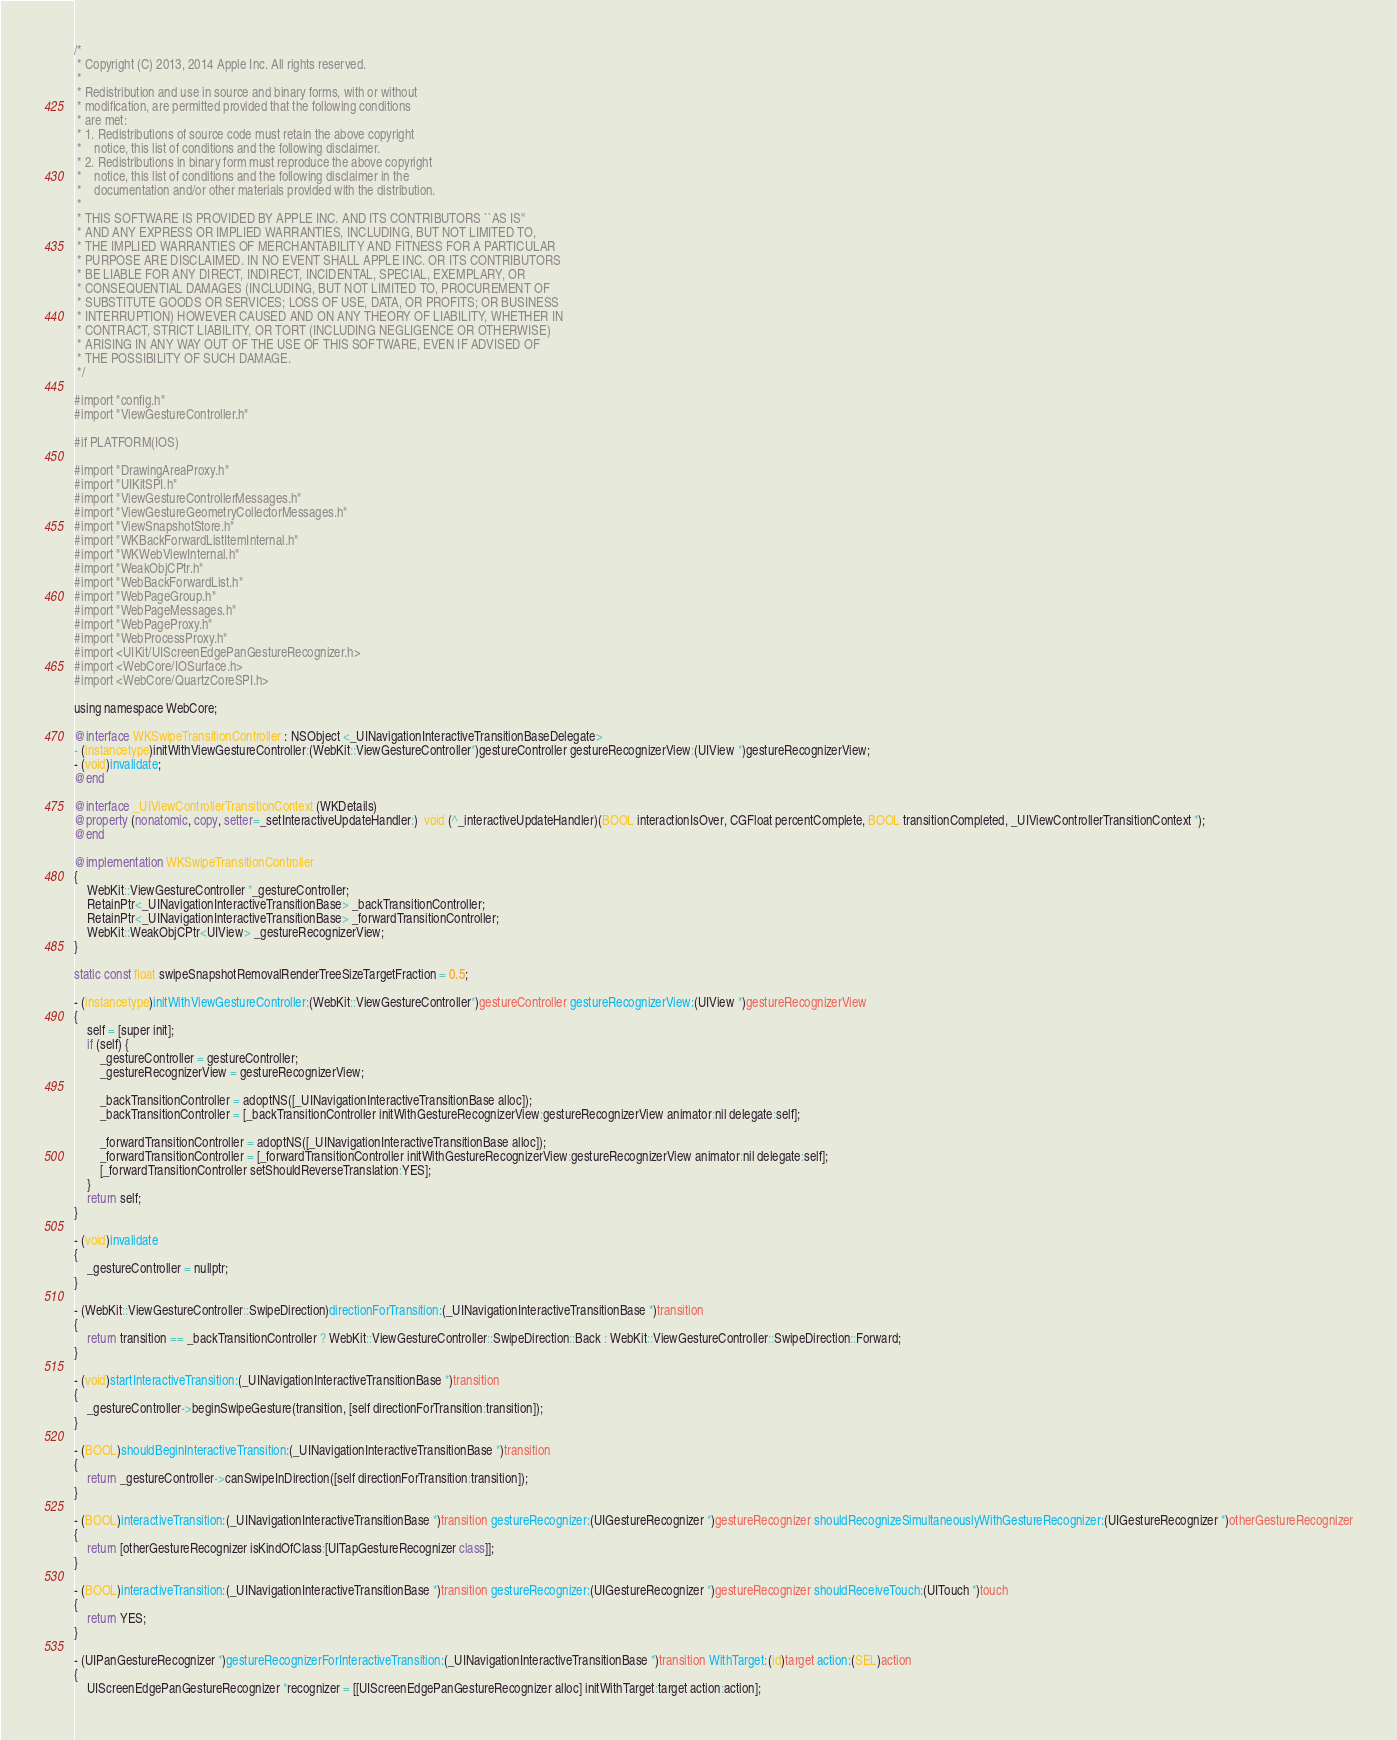<code> <loc_0><loc_0><loc_500><loc_500><_ObjectiveC_>/*
 * Copyright (C) 2013, 2014 Apple Inc. All rights reserved.
 *
 * Redistribution and use in source and binary forms, with or without
 * modification, are permitted provided that the following conditions
 * are met:
 * 1. Redistributions of source code must retain the above copyright
 *    notice, this list of conditions and the following disclaimer.
 * 2. Redistributions in binary form must reproduce the above copyright
 *    notice, this list of conditions and the following disclaimer in the
 *    documentation and/or other materials provided with the distribution.
 *
 * THIS SOFTWARE IS PROVIDED BY APPLE INC. AND ITS CONTRIBUTORS ``AS IS''
 * AND ANY EXPRESS OR IMPLIED WARRANTIES, INCLUDING, BUT NOT LIMITED TO,
 * THE IMPLIED WARRANTIES OF MERCHANTABILITY AND FITNESS FOR A PARTICULAR
 * PURPOSE ARE DISCLAIMED. IN NO EVENT SHALL APPLE INC. OR ITS CONTRIBUTORS
 * BE LIABLE FOR ANY DIRECT, INDIRECT, INCIDENTAL, SPECIAL, EXEMPLARY, OR
 * CONSEQUENTIAL DAMAGES (INCLUDING, BUT NOT LIMITED TO, PROCUREMENT OF
 * SUBSTITUTE GOODS OR SERVICES; LOSS OF USE, DATA, OR PROFITS; OR BUSINESS
 * INTERRUPTION) HOWEVER CAUSED AND ON ANY THEORY OF LIABILITY, WHETHER IN
 * CONTRACT, STRICT LIABILITY, OR TORT (INCLUDING NEGLIGENCE OR OTHERWISE)
 * ARISING IN ANY WAY OUT OF THE USE OF THIS SOFTWARE, EVEN IF ADVISED OF
 * THE POSSIBILITY OF SUCH DAMAGE.
 */

#import "config.h"
#import "ViewGestureController.h"

#if PLATFORM(IOS)

#import "DrawingAreaProxy.h"
#import "UIKitSPI.h"
#import "ViewGestureControllerMessages.h"
#import "ViewGestureGeometryCollectorMessages.h"
#import "ViewSnapshotStore.h"
#import "WKBackForwardListItemInternal.h"
#import "WKWebViewInternal.h"
#import "WeakObjCPtr.h"
#import "WebBackForwardList.h"
#import "WebPageGroup.h"
#import "WebPageMessages.h"
#import "WebPageProxy.h"
#import "WebProcessProxy.h"
#import <UIKit/UIScreenEdgePanGestureRecognizer.h>
#import <WebCore/IOSurface.h>
#import <WebCore/QuartzCoreSPI.h>

using namespace WebCore;

@interface WKSwipeTransitionController : NSObject <_UINavigationInteractiveTransitionBaseDelegate>
- (instancetype)initWithViewGestureController:(WebKit::ViewGestureController*)gestureController gestureRecognizerView:(UIView *)gestureRecognizerView;
- (void)invalidate;
@end

@interface _UIViewControllerTransitionContext (WKDetails)
@property (nonatomic, copy, setter=_setInteractiveUpdateHandler:)  void (^_interactiveUpdateHandler)(BOOL interactionIsOver, CGFloat percentComplete, BOOL transitionCompleted, _UIViewControllerTransitionContext *);
@end

@implementation WKSwipeTransitionController
{
    WebKit::ViewGestureController *_gestureController;
    RetainPtr<_UINavigationInteractiveTransitionBase> _backTransitionController;
    RetainPtr<_UINavigationInteractiveTransitionBase> _forwardTransitionController;
    WebKit::WeakObjCPtr<UIView> _gestureRecognizerView;
}

static const float swipeSnapshotRemovalRenderTreeSizeTargetFraction = 0.5;

- (instancetype)initWithViewGestureController:(WebKit::ViewGestureController*)gestureController gestureRecognizerView:(UIView *)gestureRecognizerView
{
    self = [super init];
    if (self) {
        _gestureController = gestureController;
        _gestureRecognizerView = gestureRecognizerView;

        _backTransitionController = adoptNS([_UINavigationInteractiveTransitionBase alloc]);
        _backTransitionController = [_backTransitionController initWithGestureRecognizerView:gestureRecognizerView animator:nil delegate:self];
        
        _forwardTransitionController = adoptNS([_UINavigationInteractiveTransitionBase alloc]);
        _forwardTransitionController = [_forwardTransitionController initWithGestureRecognizerView:gestureRecognizerView animator:nil delegate:self];
        [_forwardTransitionController setShouldReverseTranslation:YES];
    }
    return self;
}

- (void)invalidate
{
    _gestureController = nullptr;
}

- (WebKit::ViewGestureController::SwipeDirection)directionForTransition:(_UINavigationInteractiveTransitionBase *)transition
{
    return transition == _backTransitionController ? WebKit::ViewGestureController::SwipeDirection::Back : WebKit::ViewGestureController::SwipeDirection::Forward;
}

- (void)startInteractiveTransition:(_UINavigationInteractiveTransitionBase *)transition
{
    _gestureController->beginSwipeGesture(transition, [self directionForTransition:transition]);
}

- (BOOL)shouldBeginInteractiveTransition:(_UINavigationInteractiveTransitionBase *)transition
{
    return _gestureController->canSwipeInDirection([self directionForTransition:transition]);
}

- (BOOL)interactiveTransition:(_UINavigationInteractiveTransitionBase *)transition gestureRecognizer:(UIGestureRecognizer *)gestureRecognizer shouldRecognizeSimultaneouslyWithGestureRecognizer:(UIGestureRecognizer *)otherGestureRecognizer
{
    return [otherGestureRecognizer isKindOfClass:[UITapGestureRecognizer class]];
}

- (BOOL)interactiveTransition:(_UINavigationInteractiveTransitionBase *)transition gestureRecognizer:(UIGestureRecognizer *)gestureRecognizer shouldReceiveTouch:(UITouch *)touch
{
    return YES;
}

- (UIPanGestureRecognizer *)gestureRecognizerForInteractiveTransition:(_UINavigationInteractiveTransitionBase *)transition WithTarget:(id)target action:(SEL)action
{
    UIScreenEdgePanGestureRecognizer *recognizer = [[UIScreenEdgePanGestureRecognizer alloc] initWithTarget:target action:action];
</code> 